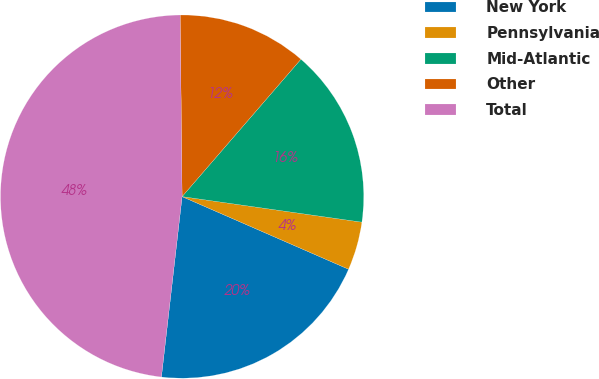Convert chart to OTSL. <chart><loc_0><loc_0><loc_500><loc_500><pie_chart><fcel>New York<fcel>Pennsylvania<fcel>Mid-Atlantic<fcel>Other<fcel>Total<nl><fcel>20.27%<fcel>4.3%<fcel>15.9%<fcel>11.52%<fcel>48.02%<nl></chart> 